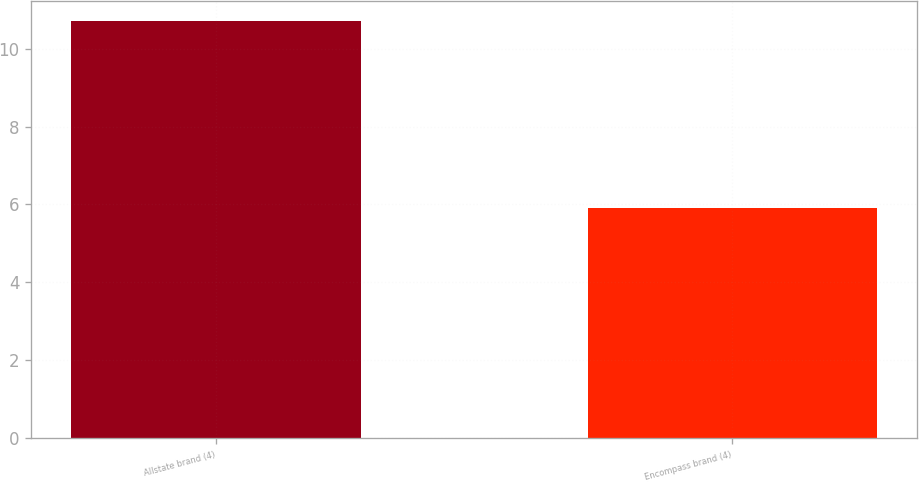Convert chart. <chart><loc_0><loc_0><loc_500><loc_500><bar_chart><fcel>Allstate brand (4)<fcel>Encompass brand (4)<nl><fcel>10.7<fcel>5.9<nl></chart> 